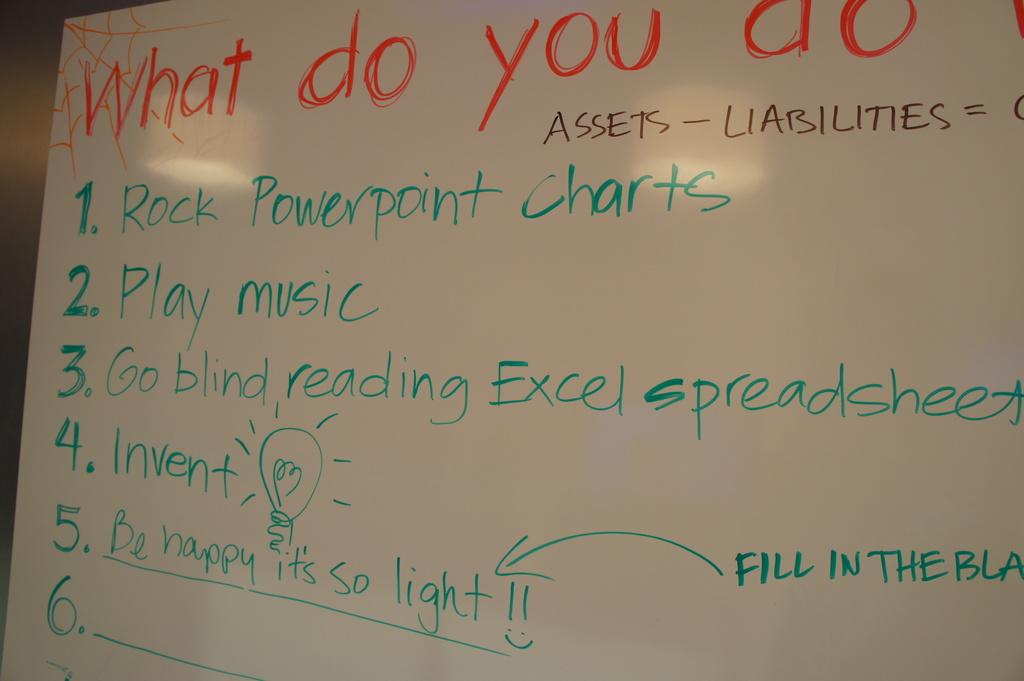Provide a one-sentence caption for the provided image. A white board with writing of a list under the heading What do you do with 5 responses. 